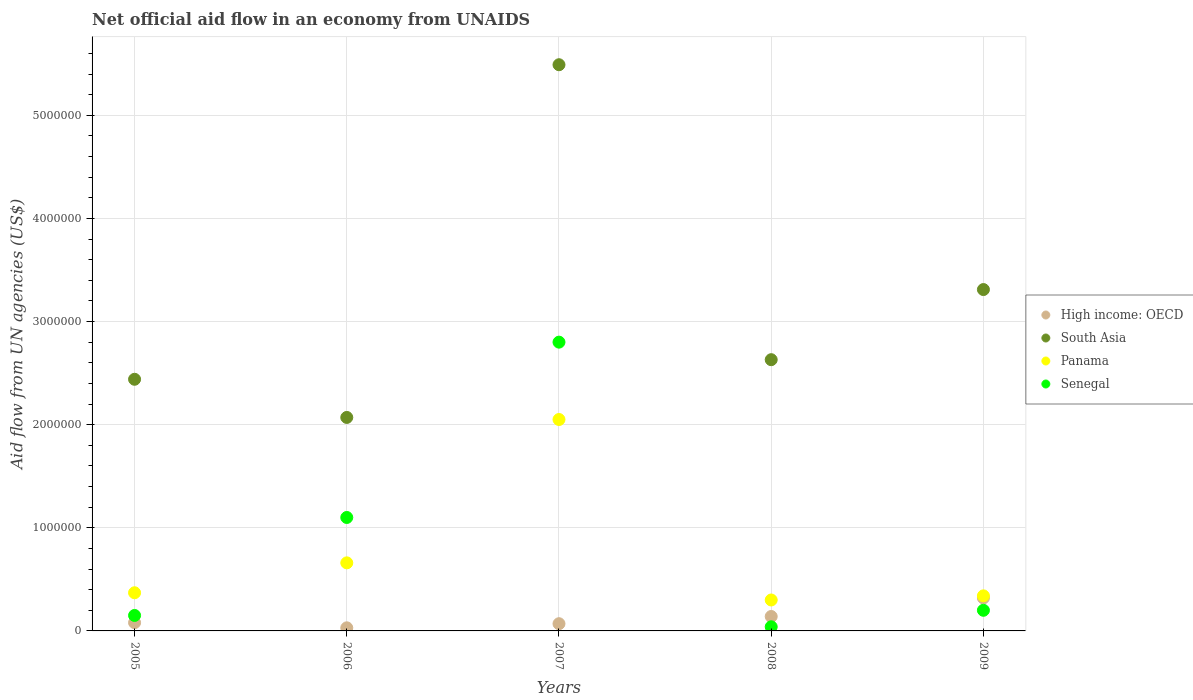How many different coloured dotlines are there?
Offer a terse response. 4. What is the net official aid flow in Panama in 2007?
Provide a succinct answer. 2.05e+06. Across all years, what is the maximum net official aid flow in South Asia?
Give a very brief answer. 5.49e+06. Across all years, what is the minimum net official aid flow in South Asia?
Give a very brief answer. 2.07e+06. In which year was the net official aid flow in South Asia maximum?
Your response must be concise. 2007. In which year was the net official aid flow in South Asia minimum?
Your answer should be very brief. 2006. What is the total net official aid flow in Senegal in the graph?
Offer a very short reply. 4.29e+06. What is the difference between the net official aid flow in High income: OECD in 2007 and that in 2008?
Offer a terse response. -7.00e+04. What is the difference between the net official aid flow in South Asia in 2005 and the net official aid flow in Senegal in 2008?
Provide a succinct answer. 2.40e+06. What is the average net official aid flow in South Asia per year?
Your answer should be very brief. 3.19e+06. In the year 2006, what is the difference between the net official aid flow in Panama and net official aid flow in Senegal?
Provide a short and direct response. -4.40e+05. What is the ratio of the net official aid flow in Senegal in 2007 to that in 2008?
Make the answer very short. 70. What is the difference between the highest and the lowest net official aid flow in Senegal?
Your answer should be compact. 2.76e+06. Is the sum of the net official aid flow in High income: OECD in 2005 and 2008 greater than the maximum net official aid flow in South Asia across all years?
Offer a terse response. No. Does the net official aid flow in High income: OECD monotonically increase over the years?
Keep it short and to the point. No. Is the net official aid flow in Panama strictly greater than the net official aid flow in Senegal over the years?
Provide a short and direct response. No. Is the net official aid flow in Panama strictly less than the net official aid flow in South Asia over the years?
Offer a very short reply. Yes. Are the values on the major ticks of Y-axis written in scientific E-notation?
Your answer should be very brief. No. Where does the legend appear in the graph?
Provide a short and direct response. Center right. How many legend labels are there?
Your answer should be very brief. 4. How are the legend labels stacked?
Provide a short and direct response. Vertical. What is the title of the graph?
Provide a succinct answer. Net official aid flow in an economy from UNAIDS. What is the label or title of the Y-axis?
Make the answer very short. Aid flow from UN agencies (US$). What is the Aid flow from UN agencies (US$) of High income: OECD in 2005?
Your answer should be very brief. 8.00e+04. What is the Aid flow from UN agencies (US$) in South Asia in 2005?
Your answer should be very brief. 2.44e+06. What is the Aid flow from UN agencies (US$) of Panama in 2005?
Ensure brevity in your answer.  3.70e+05. What is the Aid flow from UN agencies (US$) in South Asia in 2006?
Provide a short and direct response. 2.07e+06. What is the Aid flow from UN agencies (US$) of Senegal in 2006?
Make the answer very short. 1.10e+06. What is the Aid flow from UN agencies (US$) in South Asia in 2007?
Offer a very short reply. 5.49e+06. What is the Aid flow from UN agencies (US$) in Panama in 2007?
Your answer should be very brief. 2.05e+06. What is the Aid flow from UN agencies (US$) of Senegal in 2007?
Provide a succinct answer. 2.80e+06. What is the Aid flow from UN agencies (US$) in High income: OECD in 2008?
Provide a succinct answer. 1.40e+05. What is the Aid flow from UN agencies (US$) in South Asia in 2008?
Offer a terse response. 2.63e+06. What is the Aid flow from UN agencies (US$) of Panama in 2008?
Make the answer very short. 3.00e+05. What is the Aid flow from UN agencies (US$) of South Asia in 2009?
Keep it short and to the point. 3.31e+06. Across all years, what is the maximum Aid flow from UN agencies (US$) in South Asia?
Give a very brief answer. 5.49e+06. Across all years, what is the maximum Aid flow from UN agencies (US$) in Panama?
Offer a terse response. 2.05e+06. Across all years, what is the maximum Aid flow from UN agencies (US$) in Senegal?
Your answer should be very brief. 2.80e+06. Across all years, what is the minimum Aid flow from UN agencies (US$) of High income: OECD?
Offer a terse response. 3.00e+04. Across all years, what is the minimum Aid flow from UN agencies (US$) of South Asia?
Ensure brevity in your answer.  2.07e+06. What is the total Aid flow from UN agencies (US$) in High income: OECD in the graph?
Provide a succinct answer. 6.40e+05. What is the total Aid flow from UN agencies (US$) in South Asia in the graph?
Your response must be concise. 1.59e+07. What is the total Aid flow from UN agencies (US$) of Panama in the graph?
Keep it short and to the point. 3.72e+06. What is the total Aid flow from UN agencies (US$) in Senegal in the graph?
Ensure brevity in your answer.  4.29e+06. What is the difference between the Aid flow from UN agencies (US$) in Senegal in 2005 and that in 2006?
Your answer should be compact. -9.50e+05. What is the difference between the Aid flow from UN agencies (US$) of High income: OECD in 2005 and that in 2007?
Ensure brevity in your answer.  10000. What is the difference between the Aid flow from UN agencies (US$) in South Asia in 2005 and that in 2007?
Your answer should be very brief. -3.05e+06. What is the difference between the Aid flow from UN agencies (US$) in Panama in 2005 and that in 2007?
Offer a very short reply. -1.68e+06. What is the difference between the Aid flow from UN agencies (US$) in Senegal in 2005 and that in 2007?
Keep it short and to the point. -2.65e+06. What is the difference between the Aid flow from UN agencies (US$) of High income: OECD in 2005 and that in 2008?
Offer a very short reply. -6.00e+04. What is the difference between the Aid flow from UN agencies (US$) of South Asia in 2005 and that in 2008?
Offer a terse response. -1.90e+05. What is the difference between the Aid flow from UN agencies (US$) in Senegal in 2005 and that in 2008?
Your answer should be very brief. 1.10e+05. What is the difference between the Aid flow from UN agencies (US$) in High income: OECD in 2005 and that in 2009?
Your answer should be compact. -2.40e+05. What is the difference between the Aid flow from UN agencies (US$) of South Asia in 2005 and that in 2009?
Ensure brevity in your answer.  -8.70e+05. What is the difference between the Aid flow from UN agencies (US$) in Panama in 2005 and that in 2009?
Your answer should be very brief. 3.00e+04. What is the difference between the Aid flow from UN agencies (US$) in Senegal in 2005 and that in 2009?
Your response must be concise. -5.00e+04. What is the difference between the Aid flow from UN agencies (US$) of South Asia in 2006 and that in 2007?
Ensure brevity in your answer.  -3.42e+06. What is the difference between the Aid flow from UN agencies (US$) of Panama in 2006 and that in 2007?
Keep it short and to the point. -1.39e+06. What is the difference between the Aid flow from UN agencies (US$) of Senegal in 2006 and that in 2007?
Offer a terse response. -1.70e+06. What is the difference between the Aid flow from UN agencies (US$) of South Asia in 2006 and that in 2008?
Keep it short and to the point. -5.60e+05. What is the difference between the Aid flow from UN agencies (US$) of Senegal in 2006 and that in 2008?
Your response must be concise. 1.06e+06. What is the difference between the Aid flow from UN agencies (US$) in High income: OECD in 2006 and that in 2009?
Give a very brief answer. -2.90e+05. What is the difference between the Aid flow from UN agencies (US$) of South Asia in 2006 and that in 2009?
Your answer should be very brief. -1.24e+06. What is the difference between the Aid flow from UN agencies (US$) in South Asia in 2007 and that in 2008?
Your answer should be compact. 2.86e+06. What is the difference between the Aid flow from UN agencies (US$) in Panama in 2007 and that in 2008?
Your answer should be compact. 1.75e+06. What is the difference between the Aid flow from UN agencies (US$) in Senegal in 2007 and that in 2008?
Your response must be concise. 2.76e+06. What is the difference between the Aid flow from UN agencies (US$) in High income: OECD in 2007 and that in 2009?
Your answer should be very brief. -2.50e+05. What is the difference between the Aid flow from UN agencies (US$) of South Asia in 2007 and that in 2009?
Offer a terse response. 2.18e+06. What is the difference between the Aid flow from UN agencies (US$) of Panama in 2007 and that in 2009?
Offer a terse response. 1.71e+06. What is the difference between the Aid flow from UN agencies (US$) of Senegal in 2007 and that in 2009?
Ensure brevity in your answer.  2.60e+06. What is the difference between the Aid flow from UN agencies (US$) in High income: OECD in 2008 and that in 2009?
Your response must be concise. -1.80e+05. What is the difference between the Aid flow from UN agencies (US$) in South Asia in 2008 and that in 2009?
Offer a terse response. -6.80e+05. What is the difference between the Aid flow from UN agencies (US$) of Senegal in 2008 and that in 2009?
Your answer should be very brief. -1.60e+05. What is the difference between the Aid flow from UN agencies (US$) of High income: OECD in 2005 and the Aid flow from UN agencies (US$) of South Asia in 2006?
Your answer should be very brief. -1.99e+06. What is the difference between the Aid flow from UN agencies (US$) of High income: OECD in 2005 and the Aid flow from UN agencies (US$) of Panama in 2006?
Offer a very short reply. -5.80e+05. What is the difference between the Aid flow from UN agencies (US$) in High income: OECD in 2005 and the Aid flow from UN agencies (US$) in Senegal in 2006?
Your answer should be compact. -1.02e+06. What is the difference between the Aid flow from UN agencies (US$) of South Asia in 2005 and the Aid flow from UN agencies (US$) of Panama in 2006?
Make the answer very short. 1.78e+06. What is the difference between the Aid flow from UN agencies (US$) in South Asia in 2005 and the Aid flow from UN agencies (US$) in Senegal in 2006?
Ensure brevity in your answer.  1.34e+06. What is the difference between the Aid flow from UN agencies (US$) in Panama in 2005 and the Aid flow from UN agencies (US$) in Senegal in 2006?
Your answer should be very brief. -7.30e+05. What is the difference between the Aid flow from UN agencies (US$) of High income: OECD in 2005 and the Aid flow from UN agencies (US$) of South Asia in 2007?
Give a very brief answer. -5.41e+06. What is the difference between the Aid flow from UN agencies (US$) in High income: OECD in 2005 and the Aid flow from UN agencies (US$) in Panama in 2007?
Ensure brevity in your answer.  -1.97e+06. What is the difference between the Aid flow from UN agencies (US$) in High income: OECD in 2005 and the Aid flow from UN agencies (US$) in Senegal in 2007?
Offer a very short reply. -2.72e+06. What is the difference between the Aid flow from UN agencies (US$) in South Asia in 2005 and the Aid flow from UN agencies (US$) in Panama in 2007?
Make the answer very short. 3.90e+05. What is the difference between the Aid flow from UN agencies (US$) in South Asia in 2005 and the Aid flow from UN agencies (US$) in Senegal in 2007?
Your answer should be very brief. -3.60e+05. What is the difference between the Aid flow from UN agencies (US$) in Panama in 2005 and the Aid flow from UN agencies (US$) in Senegal in 2007?
Your answer should be compact. -2.43e+06. What is the difference between the Aid flow from UN agencies (US$) in High income: OECD in 2005 and the Aid flow from UN agencies (US$) in South Asia in 2008?
Make the answer very short. -2.55e+06. What is the difference between the Aid flow from UN agencies (US$) in High income: OECD in 2005 and the Aid flow from UN agencies (US$) in Panama in 2008?
Your answer should be very brief. -2.20e+05. What is the difference between the Aid flow from UN agencies (US$) of High income: OECD in 2005 and the Aid flow from UN agencies (US$) of Senegal in 2008?
Your response must be concise. 4.00e+04. What is the difference between the Aid flow from UN agencies (US$) in South Asia in 2005 and the Aid flow from UN agencies (US$) in Panama in 2008?
Your response must be concise. 2.14e+06. What is the difference between the Aid flow from UN agencies (US$) in South Asia in 2005 and the Aid flow from UN agencies (US$) in Senegal in 2008?
Make the answer very short. 2.40e+06. What is the difference between the Aid flow from UN agencies (US$) of High income: OECD in 2005 and the Aid flow from UN agencies (US$) of South Asia in 2009?
Make the answer very short. -3.23e+06. What is the difference between the Aid flow from UN agencies (US$) in South Asia in 2005 and the Aid flow from UN agencies (US$) in Panama in 2009?
Offer a terse response. 2.10e+06. What is the difference between the Aid flow from UN agencies (US$) in South Asia in 2005 and the Aid flow from UN agencies (US$) in Senegal in 2009?
Your answer should be very brief. 2.24e+06. What is the difference between the Aid flow from UN agencies (US$) in Panama in 2005 and the Aid flow from UN agencies (US$) in Senegal in 2009?
Make the answer very short. 1.70e+05. What is the difference between the Aid flow from UN agencies (US$) in High income: OECD in 2006 and the Aid flow from UN agencies (US$) in South Asia in 2007?
Provide a short and direct response. -5.46e+06. What is the difference between the Aid flow from UN agencies (US$) of High income: OECD in 2006 and the Aid flow from UN agencies (US$) of Panama in 2007?
Make the answer very short. -2.02e+06. What is the difference between the Aid flow from UN agencies (US$) of High income: OECD in 2006 and the Aid flow from UN agencies (US$) of Senegal in 2007?
Provide a short and direct response. -2.77e+06. What is the difference between the Aid flow from UN agencies (US$) of South Asia in 2006 and the Aid flow from UN agencies (US$) of Senegal in 2007?
Your response must be concise. -7.30e+05. What is the difference between the Aid flow from UN agencies (US$) in Panama in 2006 and the Aid flow from UN agencies (US$) in Senegal in 2007?
Your response must be concise. -2.14e+06. What is the difference between the Aid flow from UN agencies (US$) in High income: OECD in 2006 and the Aid flow from UN agencies (US$) in South Asia in 2008?
Your answer should be very brief. -2.60e+06. What is the difference between the Aid flow from UN agencies (US$) of High income: OECD in 2006 and the Aid flow from UN agencies (US$) of Panama in 2008?
Your answer should be compact. -2.70e+05. What is the difference between the Aid flow from UN agencies (US$) in High income: OECD in 2006 and the Aid flow from UN agencies (US$) in Senegal in 2008?
Your answer should be compact. -10000. What is the difference between the Aid flow from UN agencies (US$) in South Asia in 2006 and the Aid flow from UN agencies (US$) in Panama in 2008?
Your response must be concise. 1.77e+06. What is the difference between the Aid flow from UN agencies (US$) of South Asia in 2006 and the Aid flow from UN agencies (US$) of Senegal in 2008?
Offer a terse response. 2.03e+06. What is the difference between the Aid flow from UN agencies (US$) of Panama in 2006 and the Aid flow from UN agencies (US$) of Senegal in 2008?
Make the answer very short. 6.20e+05. What is the difference between the Aid flow from UN agencies (US$) in High income: OECD in 2006 and the Aid flow from UN agencies (US$) in South Asia in 2009?
Your answer should be compact. -3.28e+06. What is the difference between the Aid flow from UN agencies (US$) in High income: OECD in 2006 and the Aid flow from UN agencies (US$) in Panama in 2009?
Give a very brief answer. -3.10e+05. What is the difference between the Aid flow from UN agencies (US$) of South Asia in 2006 and the Aid flow from UN agencies (US$) of Panama in 2009?
Provide a succinct answer. 1.73e+06. What is the difference between the Aid flow from UN agencies (US$) in South Asia in 2006 and the Aid flow from UN agencies (US$) in Senegal in 2009?
Provide a succinct answer. 1.87e+06. What is the difference between the Aid flow from UN agencies (US$) of Panama in 2006 and the Aid flow from UN agencies (US$) of Senegal in 2009?
Make the answer very short. 4.60e+05. What is the difference between the Aid flow from UN agencies (US$) of High income: OECD in 2007 and the Aid flow from UN agencies (US$) of South Asia in 2008?
Offer a very short reply. -2.56e+06. What is the difference between the Aid flow from UN agencies (US$) in South Asia in 2007 and the Aid flow from UN agencies (US$) in Panama in 2008?
Give a very brief answer. 5.19e+06. What is the difference between the Aid flow from UN agencies (US$) of South Asia in 2007 and the Aid flow from UN agencies (US$) of Senegal in 2008?
Your answer should be very brief. 5.45e+06. What is the difference between the Aid flow from UN agencies (US$) of Panama in 2007 and the Aid flow from UN agencies (US$) of Senegal in 2008?
Make the answer very short. 2.01e+06. What is the difference between the Aid flow from UN agencies (US$) in High income: OECD in 2007 and the Aid flow from UN agencies (US$) in South Asia in 2009?
Offer a very short reply. -3.24e+06. What is the difference between the Aid flow from UN agencies (US$) of High income: OECD in 2007 and the Aid flow from UN agencies (US$) of Panama in 2009?
Provide a short and direct response. -2.70e+05. What is the difference between the Aid flow from UN agencies (US$) of High income: OECD in 2007 and the Aid flow from UN agencies (US$) of Senegal in 2009?
Keep it short and to the point. -1.30e+05. What is the difference between the Aid flow from UN agencies (US$) in South Asia in 2007 and the Aid flow from UN agencies (US$) in Panama in 2009?
Offer a very short reply. 5.15e+06. What is the difference between the Aid flow from UN agencies (US$) of South Asia in 2007 and the Aid flow from UN agencies (US$) of Senegal in 2009?
Provide a succinct answer. 5.29e+06. What is the difference between the Aid flow from UN agencies (US$) of Panama in 2007 and the Aid flow from UN agencies (US$) of Senegal in 2009?
Give a very brief answer. 1.85e+06. What is the difference between the Aid flow from UN agencies (US$) of High income: OECD in 2008 and the Aid flow from UN agencies (US$) of South Asia in 2009?
Provide a succinct answer. -3.17e+06. What is the difference between the Aid flow from UN agencies (US$) of High income: OECD in 2008 and the Aid flow from UN agencies (US$) of Panama in 2009?
Give a very brief answer. -2.00e+05. What is the difference between the Aid flow from UN agencies (US$) in South Asia in 2008 and the Aid flow from UN agencies (US$) in Panama in 2009?
Provide a succinct answer. 2.29e+06. What is the difference between the Aid flow from UN agencies (US$) of South Asia in 2008 and the Aid flow from UN agencies (US$) of Senegal in 2009?
Your answer should be compact. 2.43e+06. What is the difference between the Aid flow from UN agencies (US$) of Panama in 2008 and the Aid flow from UN agencies (US$) of Senegal in 2009?
Your answer should be very brief. 1.00e+05. What is the average Aid flow from UN agencies (US$) of High income: OECD per year?
Provide a succinct answer. 1.28e+05. What is the average Aid flow from UN agencies (US$) of South Asia per year?
Your response must be concise. 3.19e+06. What is the average Aid flow from UN agencies (US$) of Panama per year?
Offer a terse response. 7.44e+05. What is the average Aid flow from UN agencies (US$) in Senegal per year?
Offer a terse response. 8.58e+05. In the year 2005, what is the difference between the Aid flow from UN agencies (US$) of High income: OECD and Aid flow from UN agencies (US$) of South Asia?
Offer a terse response. -2.36e+06. In the year 2005, what is the difference between the Aid flow from UN agencies (US$) of High income: OECD and Aid flow from UN agencies (US$) of Panama?
Your answer should be very brief. -2.90e+05. In the year 2005, what is the difference between the Aid flow from UN agencies (US$) in South Asia and Aid flow from UN agencies (US$) in Panama?
Ensure brevity in your answer.  2.07e+06. In the year 2005, what is the difference between the Aid flow from UN agencies (US$) in South Asia and Aid flow from UN agencies (US$) in Senegal?
Your response must be concise. 2.29e+06. In the year 2005, what is the difference between the Aid flow from UN agencies (US$) of Panama and Aid flow from UN agencies (US$) of Senegal?
Ensure brevity in your answer.  2.20e+05. In the year 2006, what is the difference between the Aid flow from UN agencies (US$) of High income: OECD and Aid flow from UN agencies (US$) of South Asia?
Offer a very short reply. -2.04e+06. In the year 2006, what is the difference between the Aid flow from UN agencies (US$) of High income: OECD and Aid flow from UN agencies (US$) of Panama?
Keep it short and to the point. -6.30e+05. In the year 2006, what is the difference between the Aid flow from UN agencies (US$) of High income: OECD and Aid flow from UN agencies (US$) of Senegal?
Ensure brevity in your answer.  -1.07e+06. In the year 2006, what is the difference between the Aid flow from UN agencies (US$) in South Asia and Aid flow from UN agencies (US$) in Panama?
Give a very brief answer. 1.41e+06. In the year 2006, what is the difference between the Aid flow from UN agencies (US$) of South Asia and Aid flow from UN agencies (US$) of Senegal?
Your answer should be very brief. 9.70e+05. In the year 2006, what is the difference between the Aid flow from UN agencies (US$) of Panama and Aid flow from UN agencies (US$) of Senegal?
Offer a terse response. -4.40e+05. In the year 2007, what is the difference between the Aid flow from UN agencies (US$) of High income: OECD and Aid flow from UN agencies (US$) of South Asia?
Offer a very short reply. -5.42e+06. In the year 2007, what is the difference between the Aid flow from UN agencies (US$) of High income: OECD and Aid flow from UN agencies (US$) of Panama?
Provide a short and direct response. -1.98e+06. In the year 2007, what is the difference between the Aid flow from UN agencies (US$) in High income: OECD and Aid flow from UN agencies (US$) in Senegal?
Give a very brief answer. -2.73e+06. In the year 2007, what is the difference between the Aid flow from UN agencies (US$) in South Asia and Aid flow from UN agencies (US$) in Panama?
Provide a succinct answer. 3.44e+06. In the year 2007, what is the difference between the Aid flow from UN agencies (US$) in South Asia and Aid flow from UN agencies (US$) in Senegal?
Provide a succinct answer. 2.69e+06. In the year 2007, what is the difference between the Aid flow from UN agencies (US$) in Panama and Aid flow from UN agencies (US$) in Senegal?
Give a very brief answer. -7.50e+05. In the year 2008, what is the difference between the Aid flow from UN agencies (US$) of High income: OECD and Aid flow from UN agencies (US$) of South Asia?
Keep it short and to the point. -2.49e+06. In the year 2008, what is the difference between the Aid flow from UN agencies (US$) of High income: OECD and Aid flow from UN agencies (US$) of Panama?
Provide a succinct answer. -1.60e+05. In the year 2008, what is the difference between the Aid flow from UN agencies (US$) of South Asia and Aid flow from UN agencies (US$) of Panama?
Ensure brevity in your answer.  2.33e+06. In the year 2008, what is the difference between the Aid flow from UN agencies (US$) of South Asia and Aid flow from UN agencies (US$) of Senegal?
Your answer should be very brief. 2.59e+06. In the year 2008, what is the difference between the Aid flow from UN agencies (US$) of Panama and Aid flow from UN agencies (US$) of Senegal?
Make the answer very short. 2.60e+05. In the year 2009, what is the difference between the Aid flow from UN agencies (US$) in High income: OECD and Aid flow from UN agencies (US$) in South Asia?
Offer a terse response. -2.99e+06. In the year 2009, what is the difference between the Aid flow from UN agencies (US$) of South Asia and Aid flow from UN agencies (US$) of Panama?
Your response must be concise. 2.97e+06. In the year 2009, what is the difference between the Aid flow from UN agencies (US$) of South Asia and Aid flow from UN agencies (US$) of Senegal?
Provide a short and direct response. 3.11e+06. In the year 2009, what is the difference between the Aid flow from UN agencies (US$) in Panama and Aid flow from UN agencies (US$) in Senegal?
Give a very brief answer. 1.40e+05. What is the ratio of the Aid flow from UN agencies (US$) in High income: OECD in 2005 to that in 2006?
Your response must be concise. 2.67. What is the ratio of the Aid flow from UN agencies (US$) of South Asia in 2005 to that in 2006?
Your answer should be compact. 1.18. What is the ratio of the Aid flow from UN agencies (US$) of Panama in 2005 to that in 2006?
Your response must be concise. 0.56. What is the ratio of the Aid flow from UN agencies (US$) in Senegal in 2005 to that in 2006?
Provide a succinct answer. 0.14. What is the ratio of the Aid flow from UN agencies (US$) in High income: OECD in 2005 to that in 2007?
Offer a terse response. 1.14. What is the ratio of the Aid flow from UN agencies (US$) of South Asia in 2005 to that in 2007?
Make the answer very short. 0.44. What is the ratio of the Aid flow from UN agencies (US$) in Panama in 2005 to that in 2007?
Offer a very short reply. 0.18. What is the ratio of the Aid flow from UN agencies (US$) in Senegal in 2005 to that in 2007?
Provide a short and direct response. 0.05. What is the ratio of the Aid flow from UN agencies (US$) of South Asia in 2005 to that in 2008?
Make the answer very short. 0.93. What is the ratio of the Aid flow from UN agencies (US$) of Panama in 2005 to that in 2008?
Give a very brief answer. 1.23. What is the ratio of the Aid flow from UN agencies (US$) of Senegal in 2005 to that in 2008?
Give a very brief answer. 3.75. What is the ratio of the Aid flow from UN agencies (US$) of South Asia in 2005 to that in 2009?
Offer a terse response. 0.74. What is the ratio of the Aid flow from UN agencies (US$) of Panama in 2005 to that in 2009?
Your answer should be compact. 1.09. What is the ratio of the Aid flow from UN agencies (US$) in High income: OECD in 2006 to that in 2007?
Provide a succinct answer. 0.43. What is the ratio of the Aid flow from UN agencies (US$) of South Asia in 2006 to that in 2007?
Give a very brief answer. 0.38. What is the ratio of the Aid flow from UN agencies (US$) in Panama in 2006 to that in 2007?
Make the answer very short. 0.32. What is the ratio of the Aid flow from UN agencies (US$) in Senegal in 2006 to that in 2007?
Your response must be concise. 0.39. What is the ratio of the Aid flow from UN agencies (US$) of High income: OECD in 2006 to that in 2008?
Your answer should be very brief. 0.21. What is the ratio of the Aid flow from UN agencies (US$) of South Asia in 2006 to that in 2008?
Your response must be concise. 0.79. What is the ratio of the Aid flow from UN agencies (US$) in Panama in 2006 to that in 2008?
Your answer should be very brief. 2.2. What is the ratio of the Aid flow from UN agencies (US$) in High income: OECD in 2006 to that in 2009?
Ensure brevity in your answer.  0.09. What is the ratio of the Aid flow from UN agencies (US$) in South Asia in 2006 to that in 2009?
Offer a very short reply. 0.63. What is the ratio of the Aid flow from UN agencies (US$) in Panama in 2006 to that in 2009?
Keep it short and to the point. 1.94. What is the ratio of the Aid flow from UN agencies (US$) in South Asia in 2007 to that in 2008?
Your answer should be compact. 2.09. What is the ratio of the Aid flow from UN agencies (US$) in Panama in 2007 to that in 2008?
Your answer should be very brief. 6.83. What is the ratio of the Aid flow from UN agencies (US$) in Senegal in 2007 to that in 2008?
Offer a very short reply. 70. What is the ratio of the Aid flow from UN agencies (US$) of High income: OECD in 2007 to that in 2009?
Offer a terse response. 0.22. What is the ratio of the Aid flow from UN agencies (US$) in South Asia in 2007 to that in 2009?
Provide a succinct answer. 1.66. What is the ratio of the Aid flow from UN agencies (US$) of Panama in 2007 to that in 2009?
Your answer should be compact. 6.03. What is the ratio of the Aid flow from UN agencies (US$) in Senegal in 2007 to that in 2009?
Make the answer very short. 14. What is the ratio of the Aid flow from UN agencies (US$) in High income: OECD in 2008 to that in 2009?
Your answer should be very brief. 0.44. What is the ratio of the Aid flow from UN agencies (US$) of South Asia in 2008 to that in 2009?
Your answer should be compact. 0.79. What is the ratio of the Aid flow from UN agencies (US$) of Panama in 2008 to that in 2009?
Ensure brevity in your answer.  0.88. What is the difference between the highest and the second highest Aid flow from UN agencies (US$) in South Asia?
Provide a short and direct response. 2.18e+06. What is the difference between the highest and the second highest Aid flow from UN agencies (US$) in Panama?
Make the answer very short. 1.39e+06. What is the difference between the highest and the second highest Aid flow from UN agencies (US$) in Senegal?
Provide a succinct answer. 1.70e+06. What is the difference between the highest and the lowest Aid flow from UN agencies (US$) in High income: OECD?
Your answer should be very brief. 2.90e+05. What is the difference between the highest and the lowest Aid flow from UN agencies (US$) in South Asia?
Offer a terse response. 3.42e+06. What is the difference between the highest and the lowest Aid flow from UN agencies (US$) of Panama?
Provide a short and direct response. 1.75e+06. What is the difference between the highest and the lowest Aid flow from UN agencies (US$) in Senegal?
Your answer should be compact. 2.76e+06. 